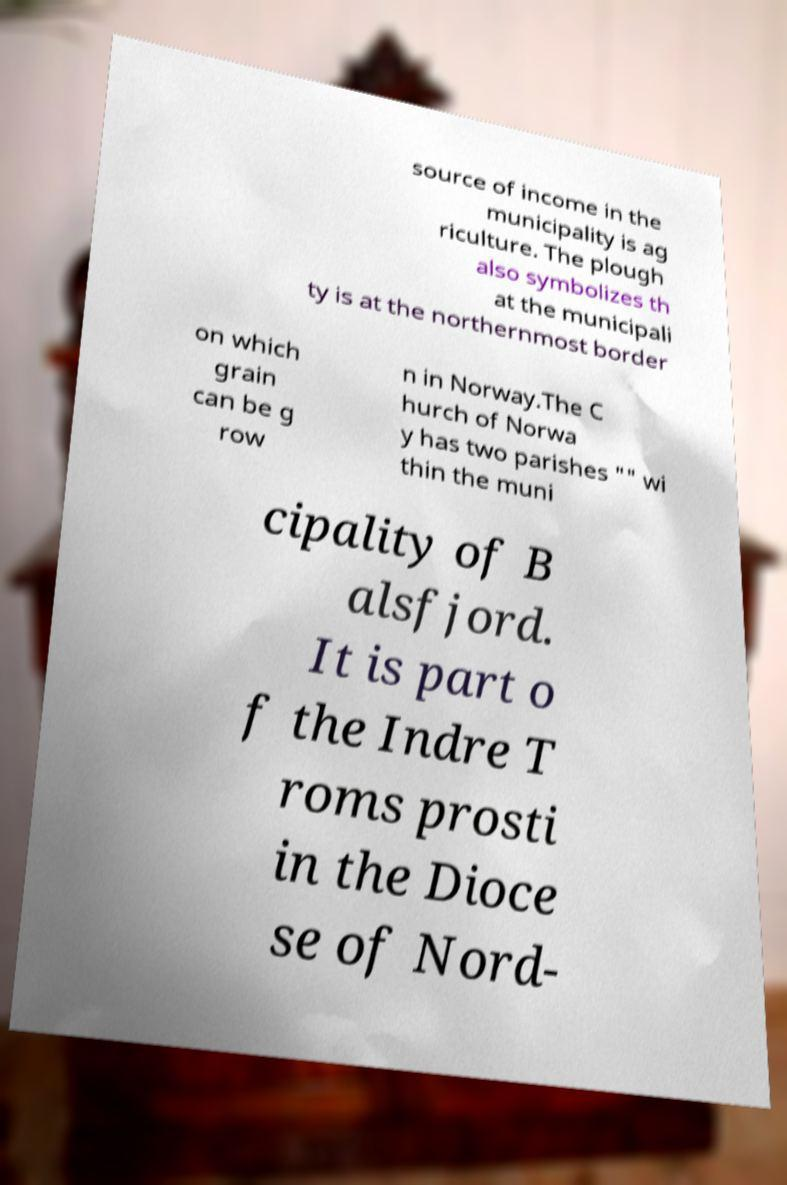Can you read and provide the text displayed in the image?This photo seems to have some interesting text. Can you extract and type it out for me? source of income in the municipality is ag riculture. The plough also symbolizes th at the municipali ty is at the northernmost border on which grain can be g row n in Norway.The C hurch of Norwa y has two parishes "" wi thin the muni cipality of B alsfjord. It is part o f the Indre T roms prosti in the Dioce se of Nord- 